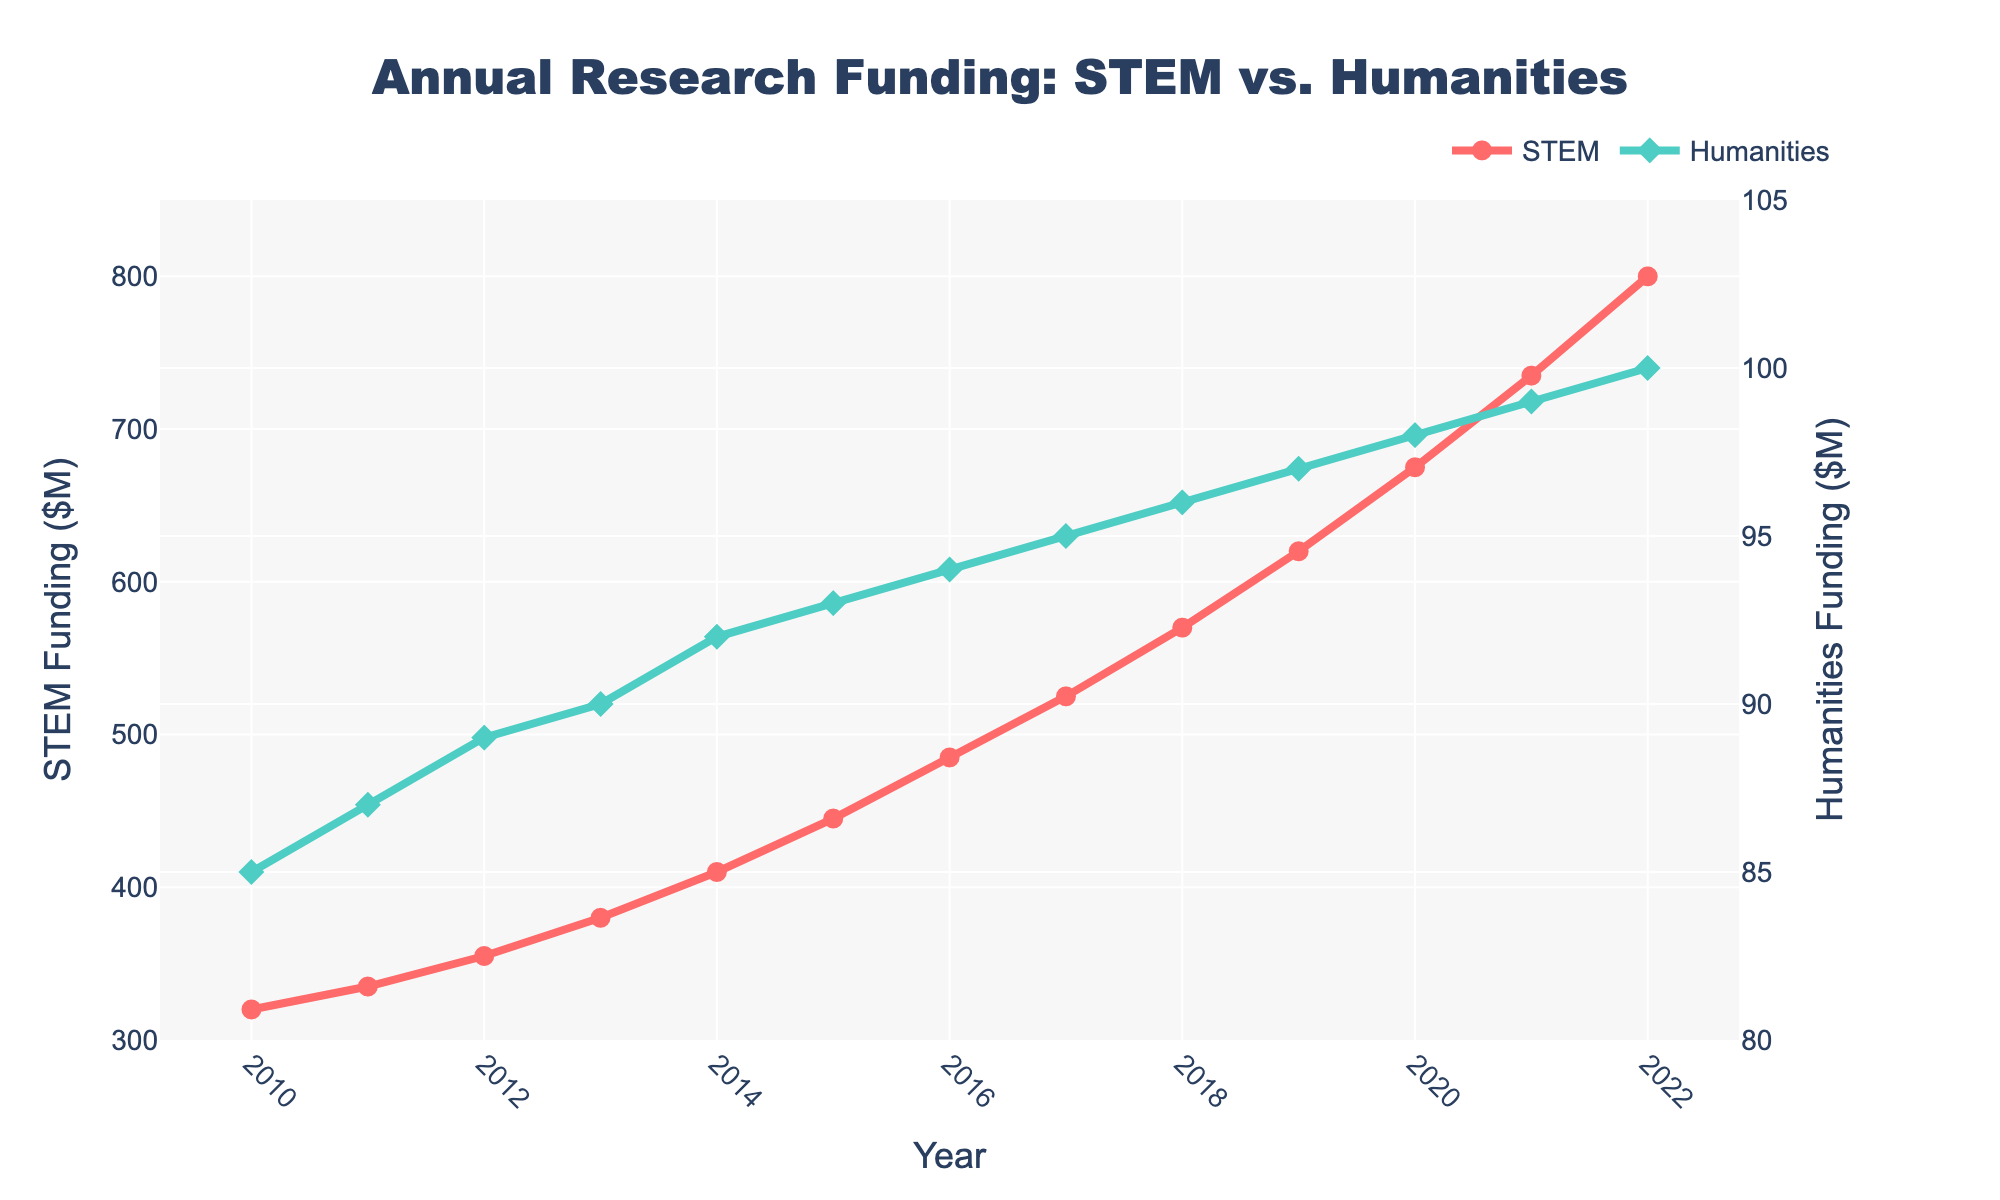What is the trend in STEM funding from 2010 to 2022? Look at the STEM funding data points from 2010 to 2022. The funding increases every year, indicating a positive and consistent upward trend.
Answer: Increasing trend How does the growth in Humanities funding from 2010 to 2022 compare to the growth in STEM funding? The initial Humanities funding in 2010 was $85M and increased to $100M in 2022, a growth of $15M. STEM funding grew from $320M in 2010 to $800M in 2022, a growth of $480M. Therefore, STEM funding grew much more compared to Humanities funding.
Answer: STEM funding grew more What is the difference in funding between STEM and Humanities in 2022? In 2022, STEM funding was $800M, and Humanities funding was $100M. The difference is $800M - $100M = $700M.
Answer: $700M During which year does STEM funding surpass $500M? Observe the STEM funding data points. In 2017, STEM funding is $525M, which is the first instance it surpasses $500M.
Answer: 2017 What is the average annual funding for Humanities from 2010 to 2022? Sum the Humanities funding from 2010 to 2022 and divide by the number of years (13). The total is $1241M, so the average is 1241 / 13 ≈ $95.46M.
Answer: Approximately $95.46M Which year has the smallest gap between STEM and Humanities funding? Calculate the gap for each year and observe the smallest one. The smallest gap is in 2010 with a gap of $320M - $85M = $235M.
Answer: 2010 In which year does Humanities funding first reach $95M? Look at the Humanities funding data points. In 2017, Humanities funding reaches $95M for the first time.
Answer: 2017 What is the combined total funding for both STEM and Humanities in 2020? Add STEM funding ($675M) and Humanities funding ($98M) for 2020. The combined total is $675M + $98M = $773M.
Answer: $773M How much did STEM funding increase from 2015 to 2020? Subtract the 2015 STEM funding ($445M) from the 2020 STEM funding ($675M). The increase is $675M - $445M = $230M.
Answer: $230M 